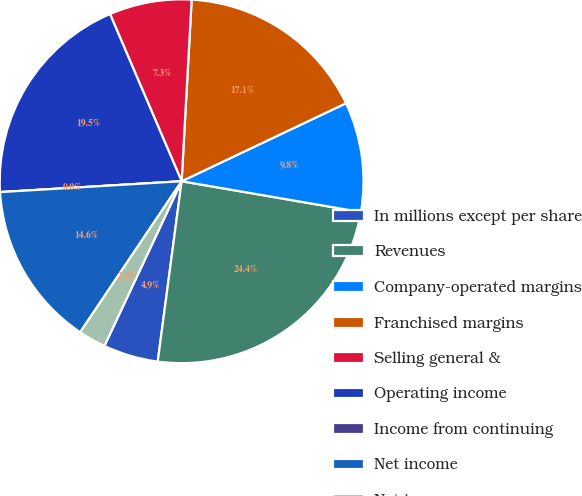Convert chart. <chart><loc_0><loc_0><loc_500><loc_500><pie_chart><fcel>In millions except per share<fcel>Revenues<fcel>Company-operated margins<fcel>Franchised margins<fcel>Selling general &<fcel>Operating income<fcel>Income from continuing<fcel>Net income<fcel>Net income per common<nl><fcel>4.88%<fcel>24.39%<fcel>9.76%<fcel>17.07%<fcel>7.32%<fcel>19.51%<fcel>0.0%<fcel>14.63%<fcel>2.44%<nl></chart> 